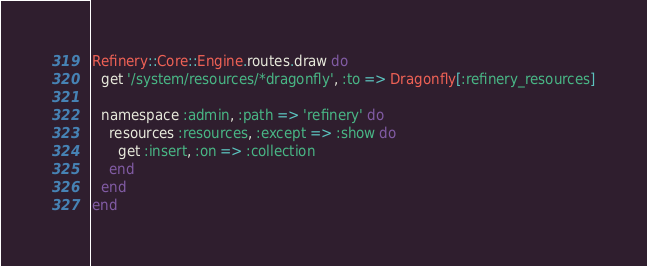Convert code to text. <code><loc_0><loc_0><loc_500><loc_500><_Ruby_>Refinery::Core::Engine.routes.draw do
  get '/system/resources/*dragonfly', :to => Dragonfly[:refinery_resources]

  namespace :admin, :path => 'refinery' do
    resources :resources, :except => :show do
      get :insert, :on => :collection
    end
  end
end
</code> 